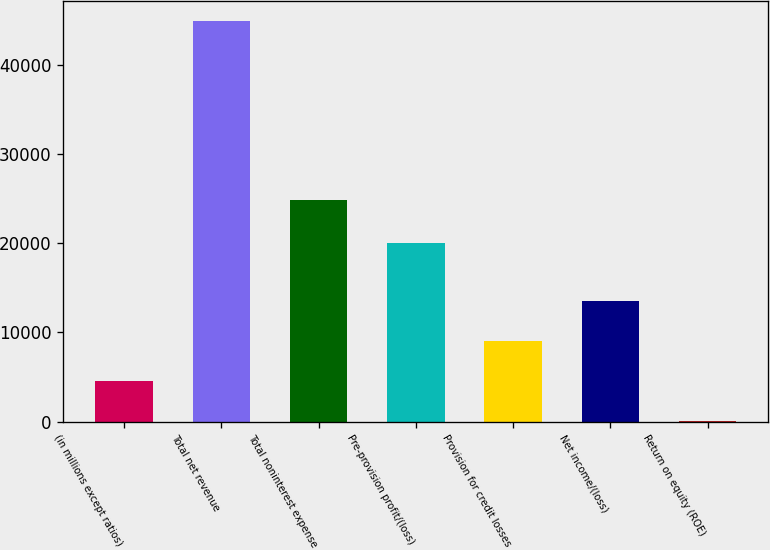<chart> <loc_0><loc_0><loc_500><loc_500><bar_chart><fcel>(in millions except ratios)<fcel>Total net revenue<fcel>Total noninterest expense<fcel>Pre-provision profit/(loss)<fcel>Provision for credit losses<fcel>Net income/(loss)<fcel>Return on equity (ROE)<nl><fcel>4507.7<fcel>44915<fcel>24905<fcel>20010<fcel>8997.4<fcel>13487.1<fcel>18<nl></chart> 